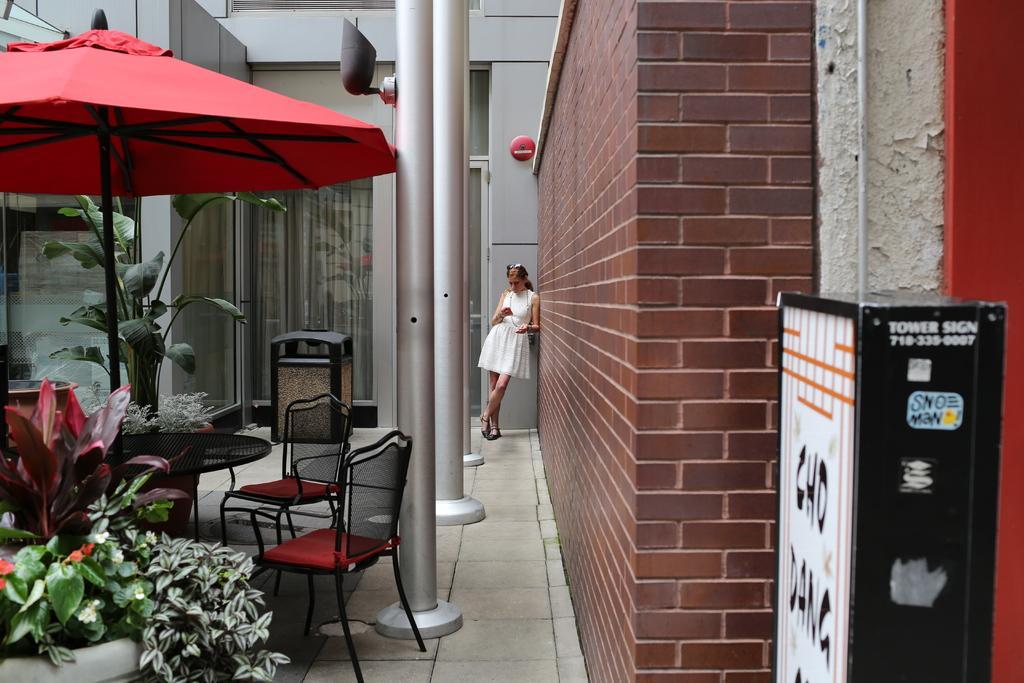How would you summarize this image in a sentence or two? this picture shows a couple of chairs and a umbrella and a woman standing and we see few plants 